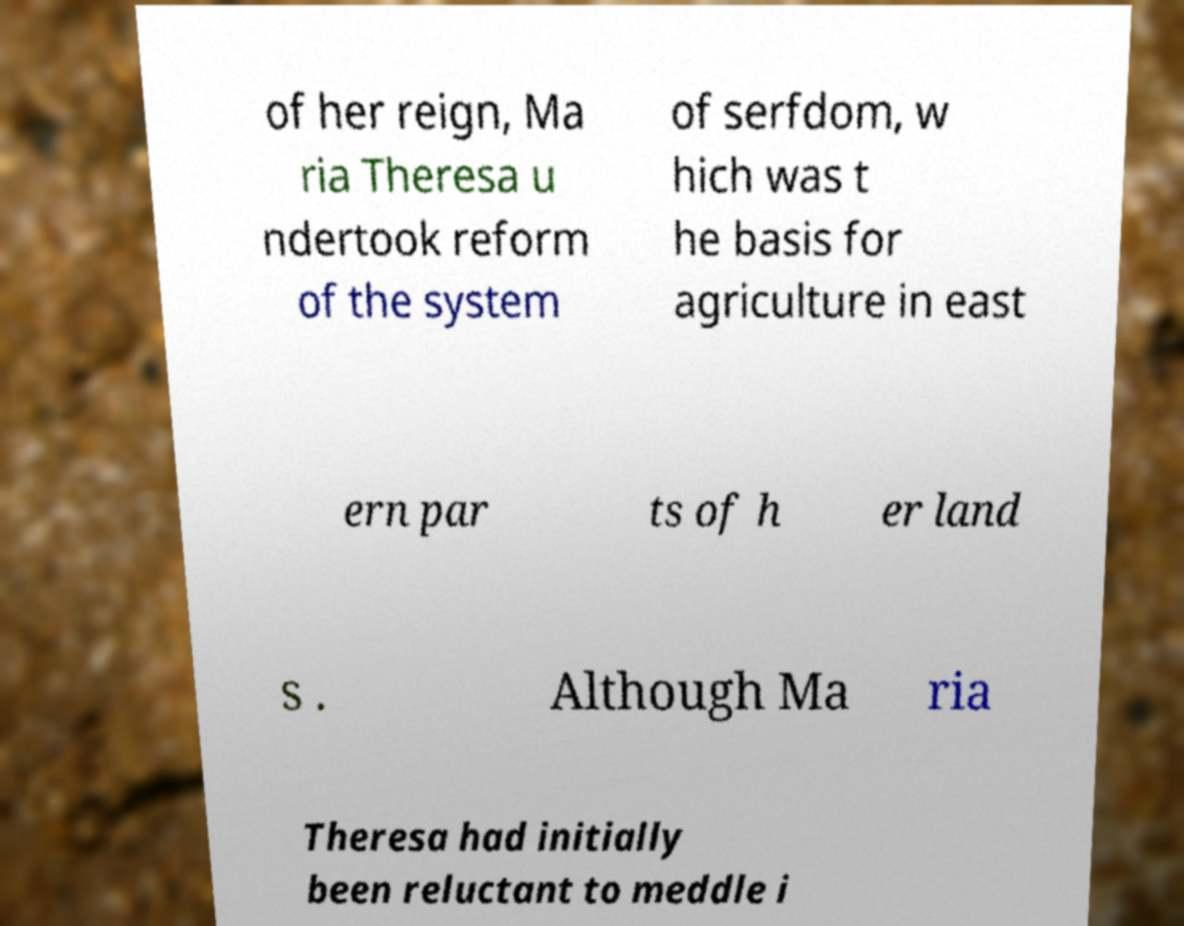Could you assist in decoding the text presented in this image and type it out clearly? of her reign, Ma ria Theresa u ndertook reform of the system of serfdom, w hich was t he basis for agriculture in east ern par ts of h er land s . Although Ma ria Theresa had initially been reluctant to meddle i 